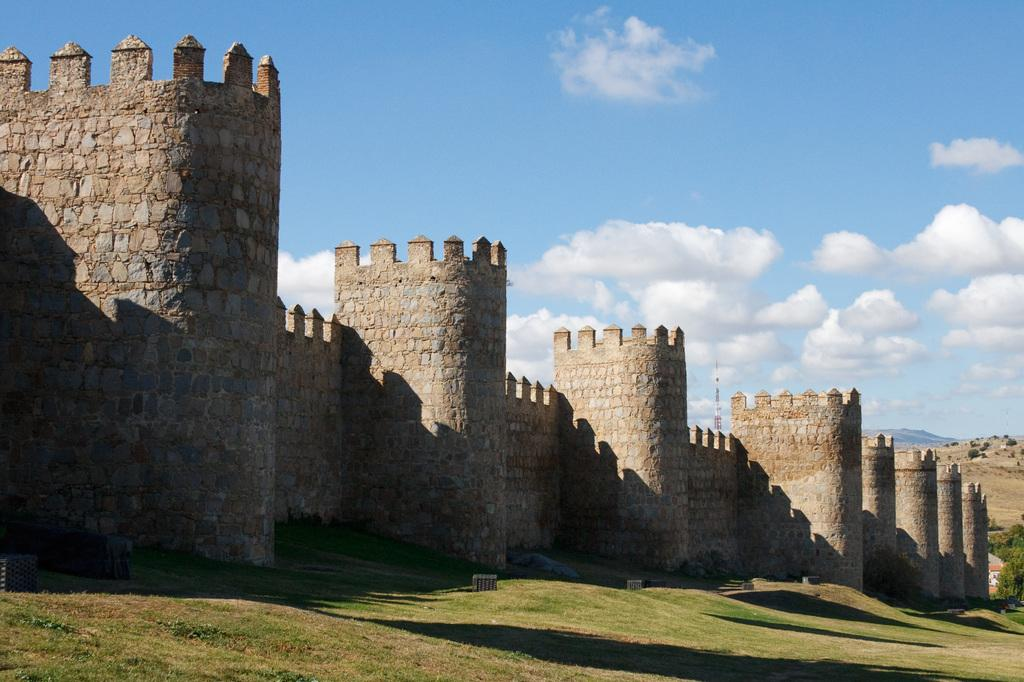What type of natural environment is depicted in the image? There is a forest in the image. What specific features can be seen in the forest? There are trees in the image. What man-made structure is present in the image? There is a tower in the image. What objects can be found on the ground in the image? There are objects on the ground in the image. What is visible in the sky at the top of the image? There are clouds visible at the top of the image. What type of growth can be seen on the hook in the image? There is no hook present in the image, so no growth can be observed on it. 